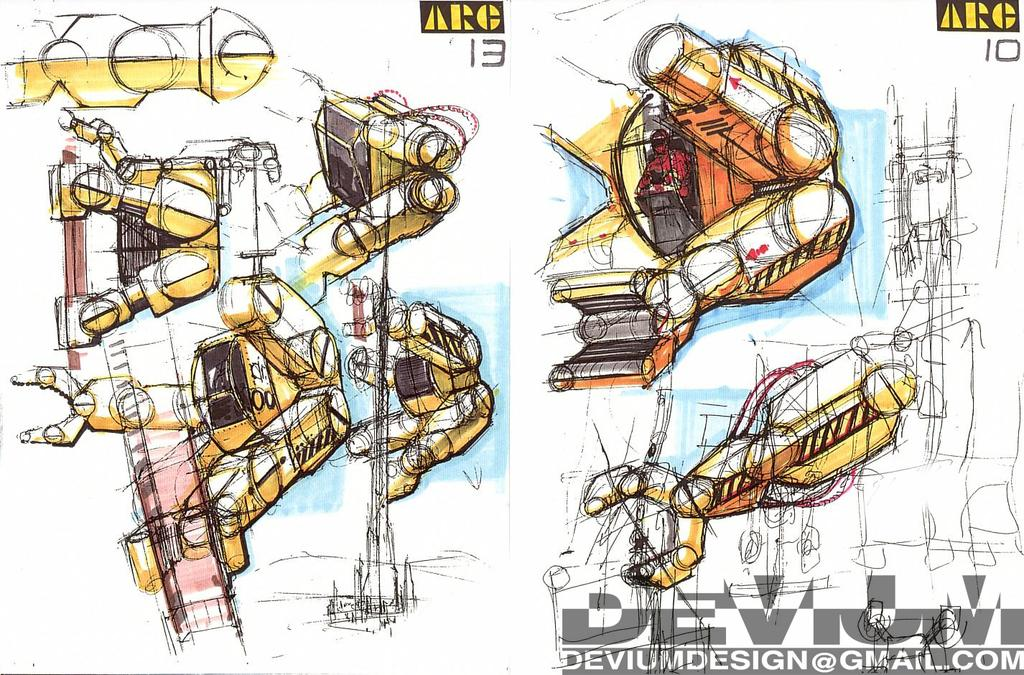What type of image is depicted in the picture? The image appears to be a poster. What is the main theme of the poster? The poster contains designs of machines and robots. Is there any text present on the poster? Yes, there is text written on the poster. How does the bee balance on the robot's head in the image? There is no bee present in the image; the poster features designs of machines and robots. What type of body is shown in the image? The image does not depict a specific body; it contains designs of machines and robots. 